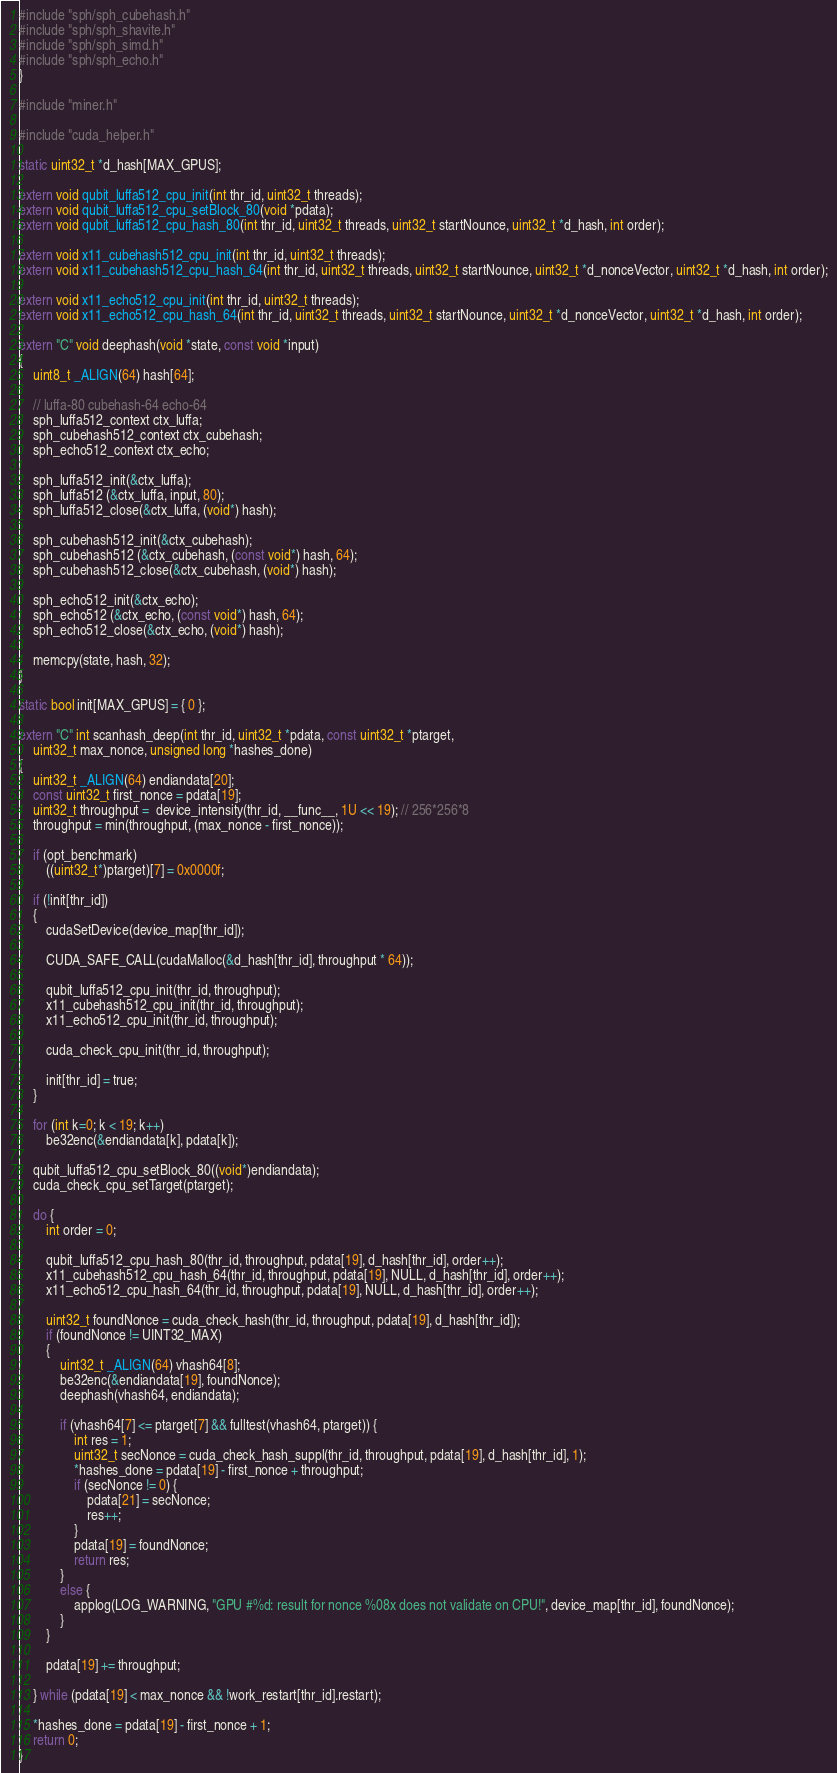Convert code to text. <code><loc_0><loc_0><loc_500><loc_500><_Cuda_>#include "sph/sph_cubehash.h"
#include "sph/sph_shavite.h"
#include "sph/sph_simd.h"
#include "sph/sph_echo.h"
}

#include "miner.h"

#include "cuda_helper.h"

static uint32_t *d_hash[MAX_GPUS];

extern void qubit_luffa512_cpu_init(int thr_id, uint32_t threads);
extern void qubit_luffa512_cpu_setBlock_80(void *pdata);
extern void qubit_luffa512_cpu_hash_80(int thr_id, uint32_t threads, uint32_t startNounce, uint32_t *d_hash, int order);

extern void x11_cubehash512_cpu_init(int thr_id, uint32_t threads);
extern void x11_cubehash512_cpu_hash_64(int thr_id, uint32_t threads, uint32_t startNounce, uint32_t *d_nonceVector, uint32_t *d_hash, int order);

extern void x11_echo512_cpu_init(int thr_id, uint32_t threads);
extern void x11_echo512_cpu_hash_64(int thr_id, uint32_t threads, uint32_t startNounce, uint32_t *d_nonceVector, uint32_t *d_hash, int order);

extern "C" void deephash(void *state, const void *input)
{
	uint8_t _ALIGN(64) hash[64];

	// luffa-80 cubehash-64 echo-64
	sph_luffa512_context ctx_luffa;
	sph_cubehash512_context ctx_cubehash;
	sph_echo512_context ctx_echo;

	sph_luffa512_init(&ctx_luffa);
	sph_luffa512 (&ctx_luffa, input, 80);
	sph_luffa512_close(&ctx_luffa, (void*) hash);

	sph_cubehash512_init(&ctx_cubehash);
	sph_cubehash512 (&ctx_cubehash, (const void*) hash, 64);
	sph_cubehash512_close(&ctx_cubehash, (void*) hash);

	sph_echo512_init(&ctx_echo);
	sph_echo512 (&ctx_echo, (const void*) hash, 64);
	sph_echo512_close(&ctx_echo, (void*) hash);

	memcpy(state, hash, 32);
}

static bool init[MAX_GPUS] = { 0 };

extern "C" int scanhash_deep(int thr_id, uint32_t *pdata, const uint32_t *ptarget,
	uint32_t max_nonce, unsigned long *hashes_done)
{
	uint32_t _ALIGN(64) endiandata[20];
	const uint32_t first_nonce = pdata[19];
	uint32_t throughput =  device_intensity(thr_id, __func__, 1U << 19); // 256*256*8
	throughput = min(throughput, (max_nonce - first_nonce));

	if (opt_benchmark)
		((uint32_t*)ptarget)[7] = 0x0000f;

	if (!init[thr_id])
	{
		cudaSetDevice(device_map[thr_id]);

		CUDA_SAFE_CALL(cudaMalloc(&d_hash[thr_id], throughput * 64));

		qubit_luffa512_cpu_init(thr_id, throughput);
		x11_cubehash512_cpu_init(thr_id, throughput);
		x11_echo512_cpu_init(thr_id, throughput);

		cuda_check_cpu_init(thr_id, throughput);

		init[thr_id] = true;
	}

	for (int k=0; k < 19; k++)
		be32enc(&endiandata[k], pdata[k]);

	qubit_luffa512_cpu_setBlock_80((void*)endiandata);
	cuda_check_cpu_setTarget(ptarget);

	do {
		int order = 0;

		qubit_luffa512_cpu_hash_80(thr_id, throughput, pdata[19], d_hash[thr_id], order++);
		x11_cubehash512_cpu_hash_64(thr_id, throughput, pdata[19], NULL, d_hash[thr_id], order++);
		x11_echo512_cpu_hash_64(thr_id, throughput, pdata[19], NULL, d_hash[thr_id], order++);

		uint32_t foundNonce = cuda_check_hash(thr_id, throughput, pdata[19], d_hash[thr_id]);
		if (foundNonce != UINT32_MAX)
		{
			uint32_t _ALIGN(64) vhash64[8];
			be32enc(&endiandata[19], foundNonce);
			deephash(vhash64, endiandata);

			if (vhash64[7] <= ptarget[7] && fulltest(vhash64, ptarget)) {
				int res = 1;
				uint32_t secNonce = cuda_check_hash_suppl(thr_id, throughput, pdata[19], d_hash[thr_id], 1);
				*hashes_done = pdata[19] - first_nonce + throughput;
				if (secNonce != 0) {
					pdata[21] = secNonce;
					res++;
				}
				pdata[19] = foundNonce;
				return res;
			}
			else {
				applog(LOG_WARNING, "GPU #%d: result for nonce %08x does not validate on CPU!", device_map[thr_id], foundNonce);
			}
		}

		pdata[19] += throughput;

	} while (pdata[19] < max_nonce && !work_restart[thr_id].restart);

	*hashes_done = pdata[19] - first_nonce + 1;
	return 0;
}
</code> 